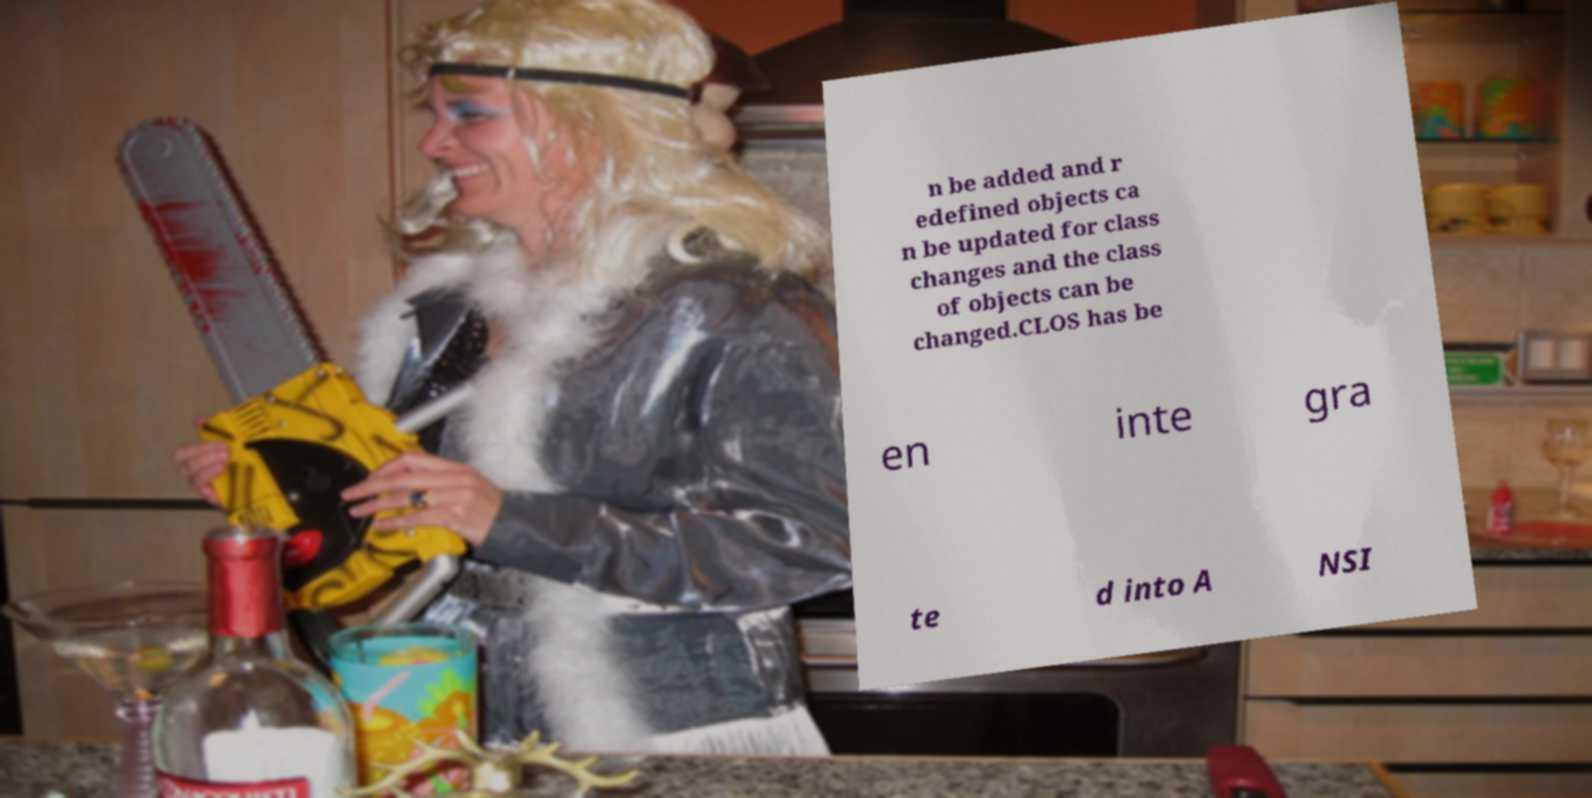Could you assist in decoding the text presented in this image and type it out clearly? n be added and r edefined objects ca n be updated for class changes and the class of objects can be changed.CLOS has be en inte gra te d into A NSI 